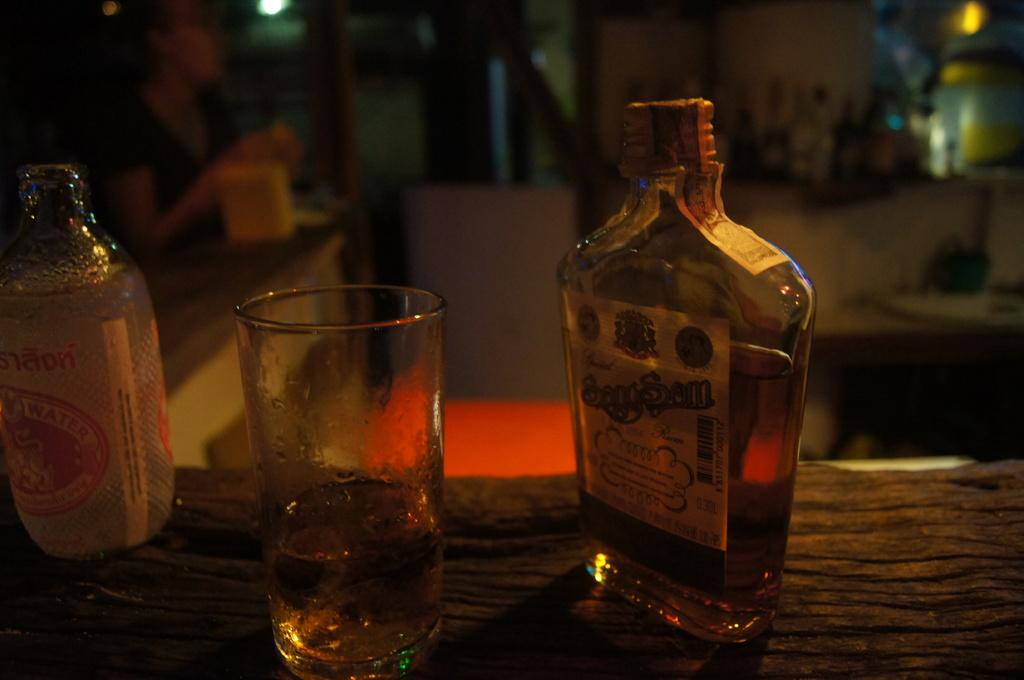<image>
Summarize the visual content of the image. A bottle of liquor that reads SongSam sits on a table next to a glass 